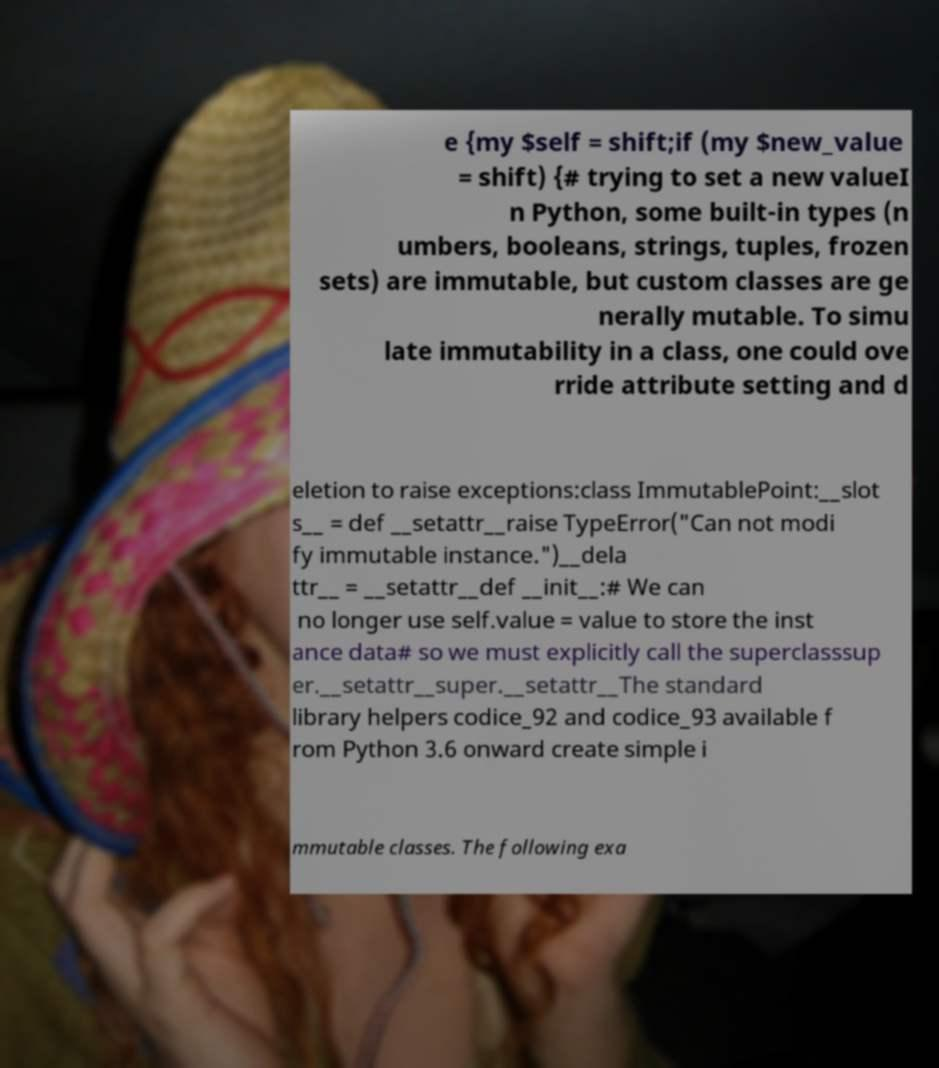Can you accurately transcribe the text from the provided image for me? e {my $self = shift;if (my $new_value = shift) {# trying to set a new valueI n Python, some built-in types (n umbers, booleans, strings, tuples, frozen sets) are immutable, but custom classes are ge nerally mutable. To simu late immutability in a class, one could ove rride attribute setting and d eletion to raise exceptions:class ImmutablePoint:__slot s__ = def __setattr__raise TypeError("Can not modi fy immutable instance.")__dela ttr__ = __setattr__def __init__:# We can no longer use self.value = value to store the inst ance data# so we must explicitly call the superclasssup er.__setattr__super.__setattr__The standard library helpers codice_92 and codice_93 available f rom Python 3.6 onward create simple i mmutable classes. The following exa 